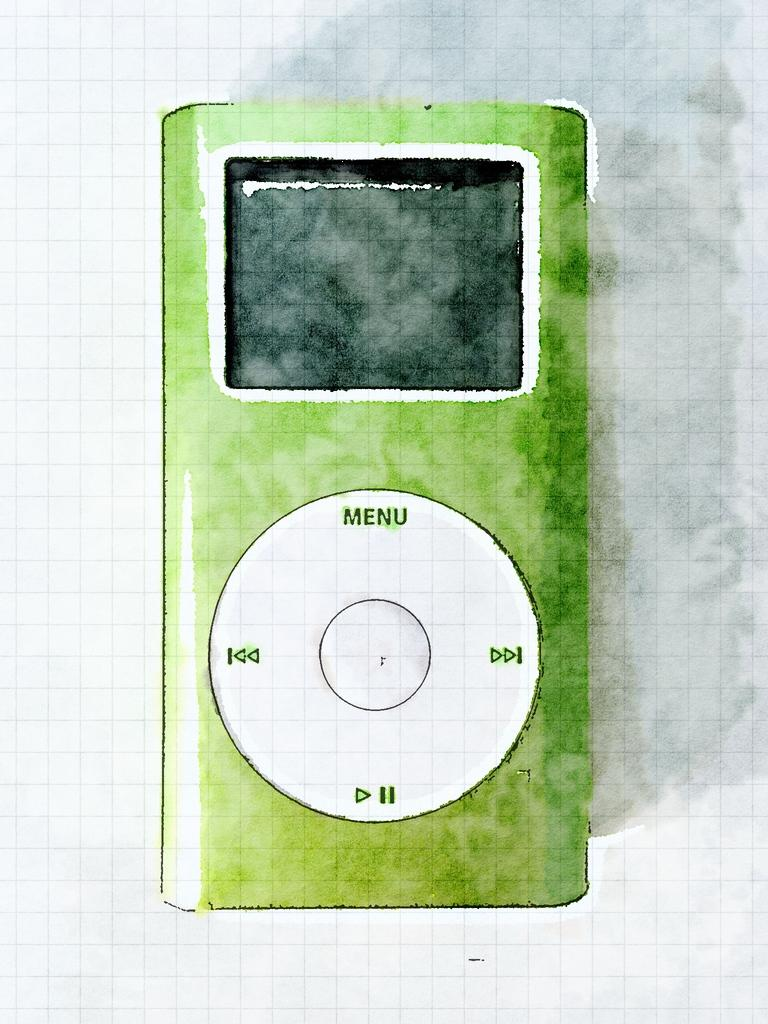What is the main subject of the image? There is a painting in the image. What does the painting depict? The painting depicts an iPod. What colors are used to represent the iPod in the painting? The iPod in the painting is green and white in color. What type of carriage is featured in the painting? There is no carriage present in the painting; it depicts an iPod. What is the plot of the painting? The painting does not have a plot, as it is a visual representation of an iPod. 